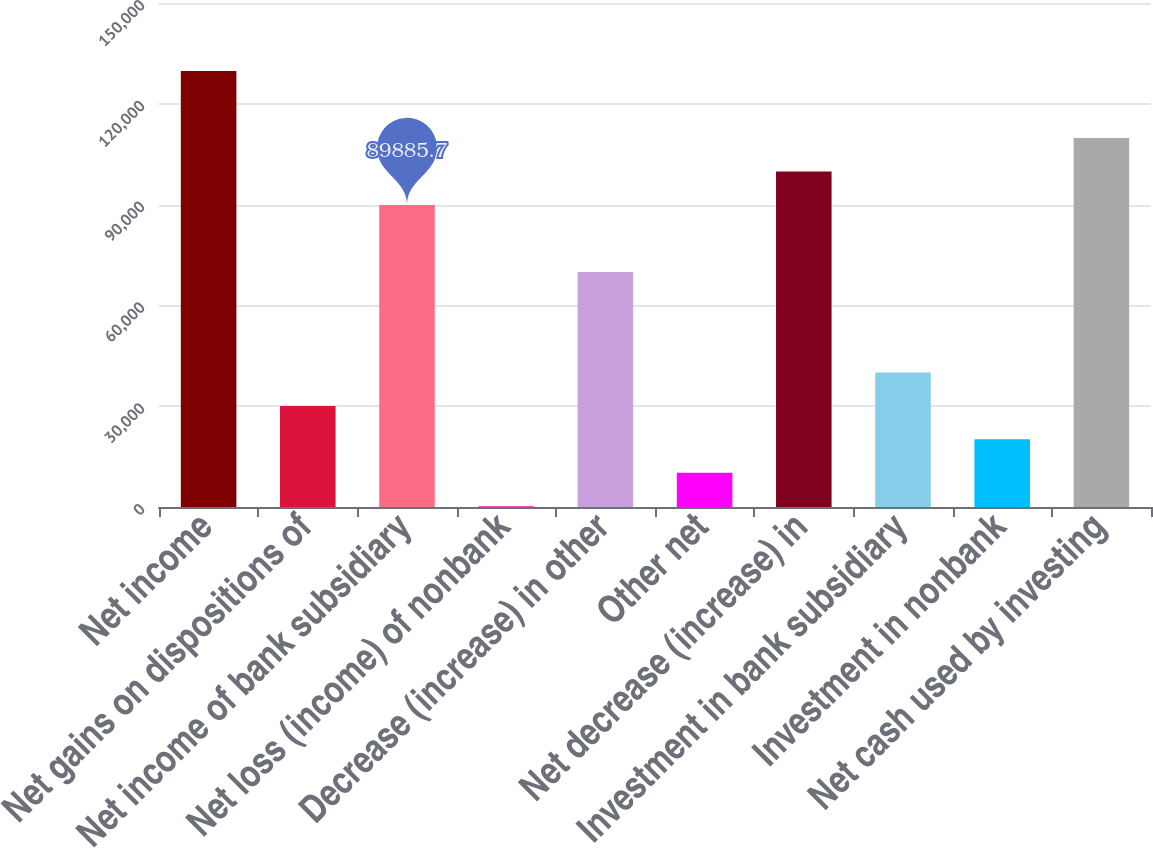<chart> <loc_0><loc_0><loc_500><loc_500><bar_chart><fcel>Net income<fcel>Net gains on dispositions of<fcel>Net income of bank subsidiary<fcel>Net loss (income) of nonbank<fcel>Decrease (increase) in other<fcel>Other net<fcel>Net decrease (increase) in<fcel>Investment in bank subsidiary<fcel>Investment in nonbank<fcel>Net cash used by investing<nl><fcel>129747<fcel>30093.9<fcel>89885.7<fcel>198<fcel>69955.1<fcel>10163.3<fcel>99851<fcel>40059.2<fcel>20128.6<fcel>109816<nl></chart> 